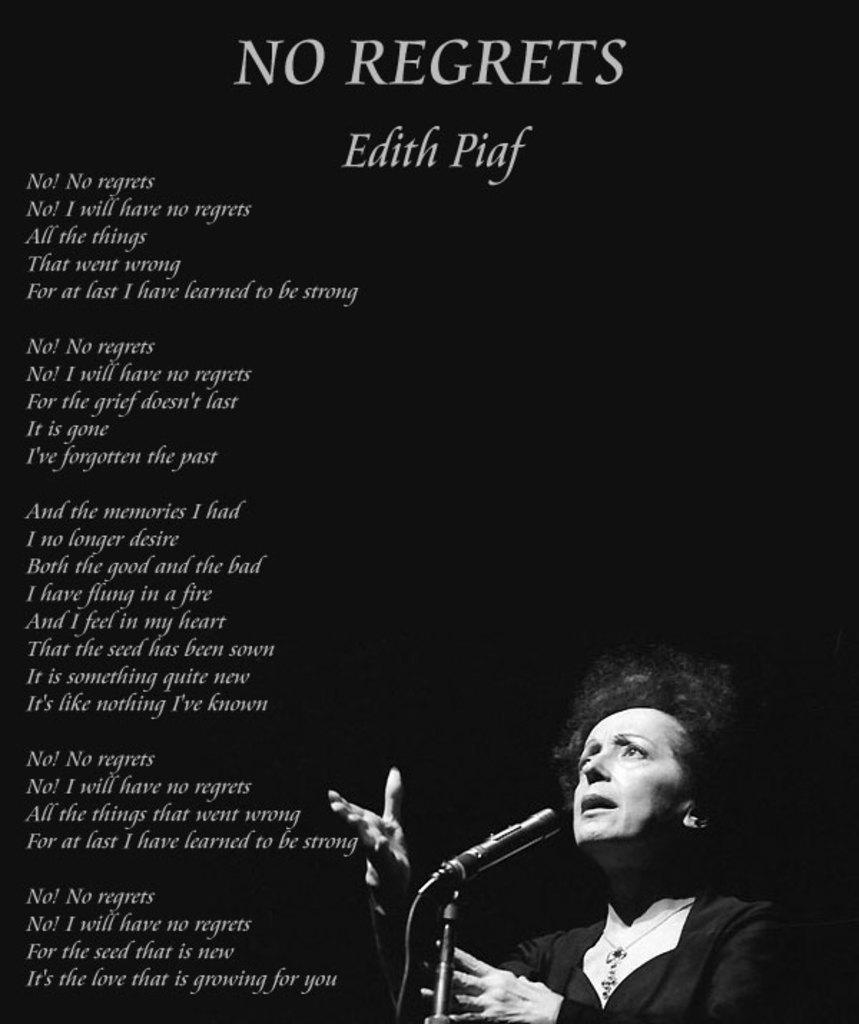Can you describe this image briefly? As we can see in the image there is a banner. On banner there is a woman wearing white color dress. There is a mic and something written. 